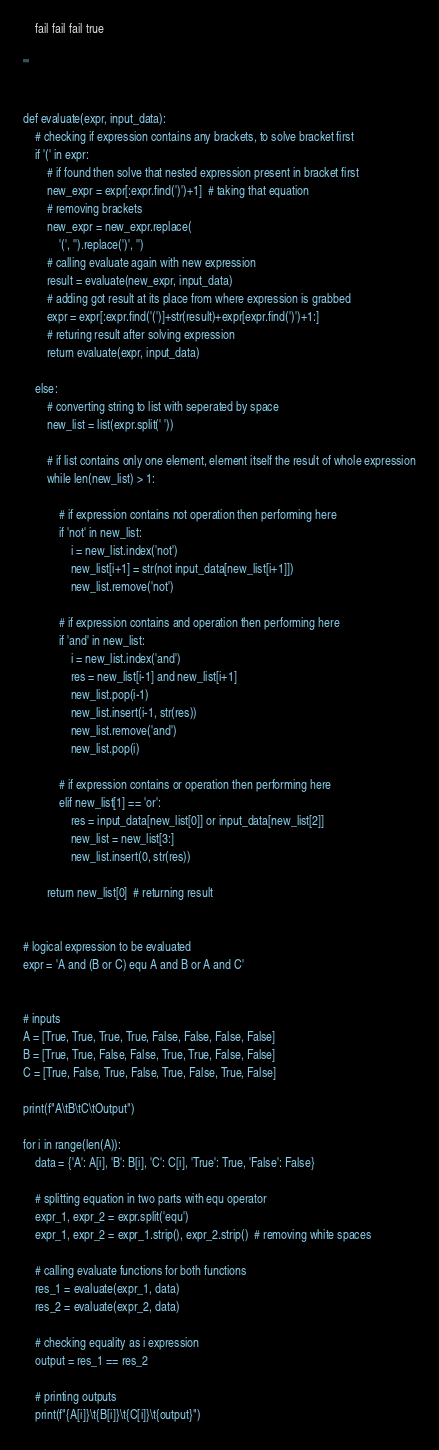Convert code to text. <code><loc_0><loc_0><loc_500><loc_500><_Python_>    fail fail fail true

'''


def evaluate(expr, input_data):
    # checking if expression contains any brackets, to solve bracket first
    if '(' in expr:
        # if found then solve that nested expression present in bracket first
        new_expr = expr[:expr.find(')')+1]  # taking that equation
        # removing brackets
        new_expr = new_expr.replace(
            '(', '').replace(')', '')
        # calling evaluate again with new expression
        result = evaluate(new_expr, input_data)
        # adding got result at its place from where expression is grabbed
        expr = expr[:expr.find('(')]+str(result)+expr[expr.find(')')+1:]
        # returing result after solving expression
        return evaluate(expr, input_data)

    else:
        # converting string to list with seperated by space
        new_list = list(expr.split(' '))

        # if list contains only one element, element itself the result of whole expression
        while len(new_list) > 1:

            # if expression contains not operation then performing here
            if 'not' in new_list:
                i = new_list.index('not')
                new_list[i+1] = str(not input_data[new_list[i+1]])
                new_list.remove('not')

            # if expression contains and operation then performing here
            if 'and' in new_list:
                i = new_list.index('and')
                res = new_list[i-1] and new_list[i+1]
                new_list.pop(i-1)
                new_list.insert(i-1, str(res))
                new_list.remove('and')
                new_list.pop(i)

            # if expression contains or operation then performing here
            elif new_list[1] == 'or':
                res = input_data[new_list[0]] or input_data[new_list[2]]
                new_list = new_list[3:]
                new_list.insert(0, str(res))

        return new_list[0]  # returning result


# logical expression to be evaluated
expr = 'A and (B or C) equ A and B or A and C'


# inputs
A = [True, True, True, True, False, False, False, False]
B = [True, True, False, False, True, True, False, False]
C = [True, False, True, False, True, False, True, False]

print(f"A\tB\tC\tOutput")

for i in range(len(A)):
    data = {'A': A[i], 'B': B[i], 'C': C[i], 'True': True, 'False': False}

    # splitting equation in two parts with equ operator
    expr_1, expr_2 = expr.split('equ')
    expr_1, expr_2 = expr_1.strip(), expr_2.strip()  # removing white spaces

    # calling evaluate functions for both functions
    res_1 = evaluate(expr_1, data)
    res_2 = evaluate(expr_2, data)

    # checking equality as i expression
    output = res_1 == res_2

    # printing outputs
    print(f"{A[i]}\t{B[i]}\t{C[i]}\t{output}")
</code> 